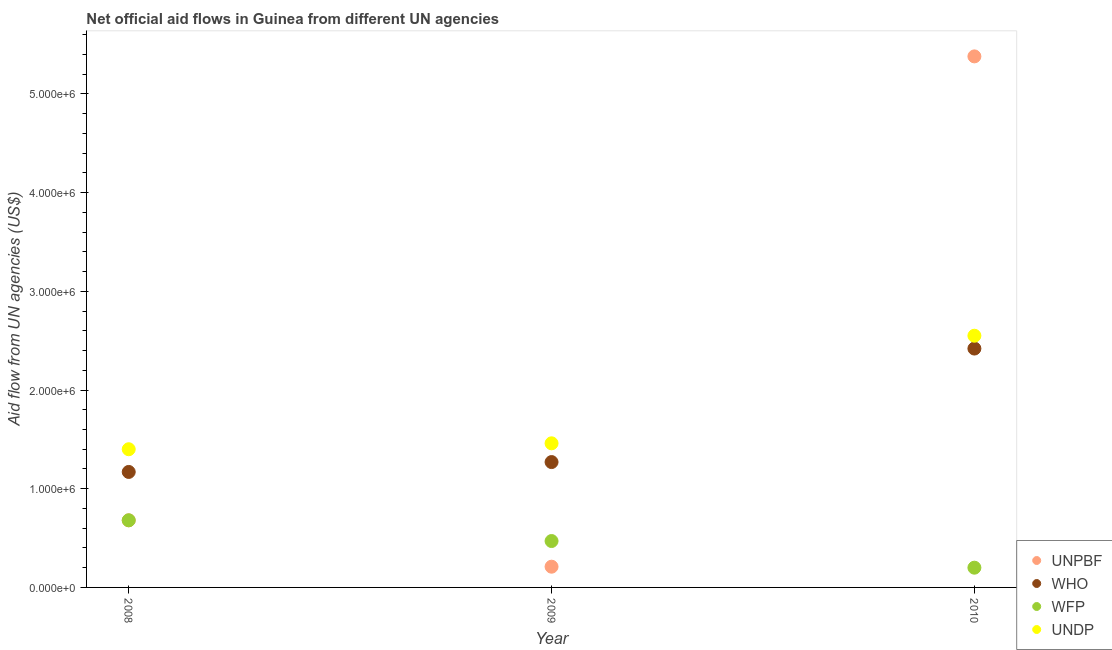What is the amount of aid given by undp in 2010?
Ensure brevity in your answer.  2.55e+06. Across all years, what is the maximum amount of aid given by who?
Keep it short and to the point. 2.42e+06. Across all years, what is the minimum amount of aid given by wfp?
Offer a very short reply. 2.00e+05. In which year was the amount of aid given by undp maximum?
Offer a terse response. 2010. What is the total amount of aid given by undp in the graph?
Your answer should be compact. 5.41e+06. What is the difference between the amount of aid given by who in 2009 and that in 2010?
Offer a terse response. -1.15e+06. What is the difference between the amount of aid given by unpbf in 2009 and the amount of aid given by who in 2008?
Make the answer very short. -9.60e+05. What is the average amount of aid given by undp per year?
Your answer should be compact. 1.80e+06. In the year 2009, what is the difference between the amount of aid given by wfp and amount of aid given by undp?
Your response must be concise. -9.90e+05. In how many years, is the amount of aid given by unpbf greater than 2600000 US$?
Your response must be concise. 1. What is the ratio of the amount of aid given by undp in 2008 to that in 2009?
Keep it short and to the point. 0.96. What is the difference between the highest and the second highest amount of aid given by unpbf?
Ensure brevity in your answer.  4.70e+06. What is the difference between the highest and the lowest amount of aid given by who?
Your answer should be very brief. 1.25e+06. In how many years, is the amount of aid given by wfp greater than the average amount of aid given by wfp taken over all years?
Offer a very short reply. 2. How many years are there in the graph?
Your response must be concise. 3. Are the values on the major ticks of Y-axis written in scientific E-notation?
Make the answer very short. Yes. Does the graph contain any zero values?
Ensure brevity in your answer.  No. Does the graph contain grids?
Give a very brief answer. No. Where does the legend appear in the graph?
Give a very brief answer. Bottom right. What is the title of the graph?
Ensure brevity in your answer.  Net official aid flows in Guinea from different UN agencies. What is the label or title of the Y-axis?
Your answer should be compact. Aid flow from UN agencies (US$). What is the Aid flow from UN agencies (US$) of UNPBF in 2008?
Offer a terse response. 6.80e+05. What is the Aid flow from UN agencies (US$) of WHO in 2008?
Ensure brevity in your answer.  1.17e+06. What is the Aid flow from UN agencies (US$) of WFP in 2008?
Provide a succinct answer. 6.80e+05. What is the Aid flow from UN agencies (US$) in UNDP in 2008?
Give a very brief answer. 1.40e+06. What is the Aid flow from UN agencies (US$) in WHO in 2009?
Keep it short and to the point. 1.27e+06. What is the Aid flow from UN agencies (US$) in UNDP in 2009?
Offer a terse response. 1.46e+06. What is the Aid flow from UN agencies (US$) of UNPBF in 2010?
Ensure brevity in your answer.  5.38e+06. What is the Aid flow from UN agencies (US$) of WHO in 2010?
Make the answer very short. 2.42e+06. What is the Aid flow from UN agencies (US$) in UNDP in 2010?
Your answer should be very brief. 2.55e+06. Across all years, what is the maximum Aid flow from UN agencies (US$) in UNPBF?
Give a very brief answer. 5.38e+06. Across all years, what is the maximum Aid flow from UN agencies (US$) in WHO?
Make the answer very short. 2.42e+06. Across all years, what is the maximum Aid flow from UN agencies (US$) of WFP?
Your answer should be very brief. 6.80e+05. Across all years, what is the maximum Aid flow from UN agencies (US$) in UNDP?
Offer a very short reply. 2.55e+06. Across all years, what is the minimum Aid flow from UN agencies (US$) in WHO?
Offer a very short reply. 1.17e+06. Across all years, what is the minimum Aid flow from UN agencies (US$) of UNDP?
Your answer should be compact. 1.40e+06. What is the total Aid flow from UN agencies (US$) in UNPBF in the graph?
Make the answer very short. 6.27e+06. What is the total Aid flow from UN agencies (US$) in WHO in the graph?
Make the answer very short. 4.86e+06. What is the total Aid flow from UN agencies (US$) in WFP in the graph?
Provide a short and direct response. 1.35e+06. What is the total Aid flow from UN agencies (US$) of UNDP in the graph?
Your answer should be very brief. 5.41e+06. What is the difference between the Aid flow from UN agencies (US$) of WHO in 2008 and that in 2009?
Make the answer very short. -1.00e+05. What is the difference between the Aid flow from UN agencies (US$) in WFP in 2008 and that in 2009?
Give a very brief answer. 2.10e+05. What is the difference between the Aid flow from UN agencies (US$) in UNPBF in 2008 and that in 2010?
Make the answer very short. -4.70e+06. What is the difference between the Aid flow from UN agencies (US$) in WHO in 2008 and that in 2010?
Your answer should be very brief. -1.25e+06. What is the difference between the Aid flow from UN agencies (US$) of WFP in 2008 and that in 2010?
Give a very brief answer. 4.80e+05. What is the difference between the Aid flow from UN agencies (US$) in UNDP in 2008 and that in 2010?
Provide a short and direct response. -1.15e+06. What is the difference between the Aid flow from UN agencies (US$) of UNPBF in 2009 and that in 2010?
Your answer should be compact. -5.17e+06. What is the difference between the Aid flow from UN agencies (US$) of WHO in 2009 and that in 2010?
Offer a very short reply. -1.15e+06. What is the difference between the Aid flow from UN agencies (US$) of UNDP in 2009 and that in 2010?
Offer a terse response. -1.09e+06. What is the difference between the Aid flow from UN agencies (US$) in UNPBF in 2008 and the Aid flow from UN agencies (US$) in WHO in 2009?
Ensure brevity in your answer.  -5.90e+05. What is the difference between the Aid flow from UN agencies (US$) in UNPBF in 2008 and the Aid flow from UN agencies (US$) in UNDP in 2009?
Keep it short and to the point. -7.80e+05. What is the difference between the Aid flow from UN agencies (US$) of WFP in 2008 and the Aid flow from UN agencies (US$) of UNDP in 2009?
Ensure brevity in your answer.  -7.80e+05. What is the difference between the Aid flow from UN agencies (US$) in UNPBF in 2008 and the Aid flow from UN agencies (US$) in WHO in 2010?
Ensure brevity in your answer.  -1.74e+06. What is the difference between the Aid flow from UN agencies (US$) of UNPBF in 2008 and the Aid flow from UN agencies (US$) of WFP in 2010?
Your answer should be compact. 4.80e+05. What is the difference between the Aid flow from UN agencies (US$) in UNPBF in 2008 and the Aid flow from UN agencies (US$) in UNDP in 2010?
Keep it short and to the point. -1.87e+06. What is the difference between the Aid flow from UN agencies (US$) in WHO in 2008 and the Aid flow from UN agencies (US$) in WFP in 2010?
Keep it short and to the point. 9.70e+05. What is the difference between the Aid flow from UN agencies (US$) in WHO in 2008 and the Aid flow from UN agencies (US$) in UNDP in 2010?
Provide a short and direct response. -1.38e+06. What is the difference between the Aid flow from UN agencies (US$) in WFP in 2008 and the Aid flow from UN agencies (US$) in UNDP in 2010?
Keep it short and to the point. -1.87e+06. What is the difference between the Aid flow from UN agencies (US$) of UNPBF in 2009 and the Aid flow from UN agencies (US$) of WHO in 2010?
Ensure brevity in your answer.  -2.21e+06. What is the difference between the Aid flow from UN agencies (US$) in UNPBF in 2009 and the Aid flow from UN agencies (US$) in UNDP in 2010?
Your answer should be very brief. -2.34e+06. What is the difference between the Aid flow from UN agencies (US$) in WHO in 2009 and the Aid flow from UN agencies (US$) in WFP in 2010?
Make the answer very short. 1.07e+06. What is the difference between the Aid flow from UN agencies (US$) of WHO in 2009 and the Aid flow from UN agencies (US$) of UNDP in 2010?
Give a very brief answer. -1.28e+06. What is the difference between the Aid flow from UN agencies (US$) of WFP in 2009 and the Aid flow from UN agencies (US$) of UNDP in 2010?
Offer a terse response. -2.08e+06. What is the average Aid flow from UN agencies (US$) of UNPBF per year?
Your response must be concise. 2.09e+06. What is the average Aid flow from UN agencies (US$) of WHO per year?
Your answer should be compact. 1.62e+06. What is the average Aid flow from UN agencies (US$) of UNDP per year?
Keep it short and to the point. 1.80e+06. In the year 2008, what is the difference between the Aid flow from UN agencies (US$) of UNPBF and Aid flow from UN agencies (US$) of WHO?
Offer a terse response. -4.90e+05. In the year 2008, what is the difference between the Aid flow from UN agencies (US$) in UNPBF and Aid flow from UN agencies (US$) in WFP?
Ensure brevity in your answer.  0. In the year 2008, what is the difference between the Aid flow from UN agencies (US$) in UNPBF and Aid flow from UN agencies (US$) in UNDP?
Provide a succinct answer. -7.20e+05. In the year 2008, what is the difference between the Aid flow from UN agencies (US$) of WHO and Aid flow from UN agencies (US$) of UNDP?
Provide a succinct answer. -2.30e+05. In the year 2008, what is the difference between the Aid flow from UN agencies (US$) in WFP and Aid flow from UN agencies (US$) in UNDP?
Provide a succinct answer. -7.20e+05. In the year 2009, what is the difference between the Aid flow from UN agencies (US$) in UNPBF and Aid flow from UN agencies (US$) in WHO?
Provide a succinct answer. -1.06e+06. In the year 2009, what is the difference between the Aid flow from UN agencies (US$) of UNPBF and Aid flow from UN agencies (US$) of WFP?
Provide a short and direct response. -2.60e+05. In the year 2009, what is the difference between the Aid flow from UN agencies (US$) of UNPBF and Aid flow from UN agencies (US$) of UNDP?
Ensure brevity in your answer.  -1.25e+06. In the year 2009, what is the difference between the Aid flow from UN agencies (US$) in WHO and Aid flow from UN agencies (US$) in WFP?
Your answer should be very brief. 8.00e+05. In the year 2009, what is the difference between the Aid flow from UN agencies (US$) of WHO and Aid flow from UN agencies (US$) of UNDP?
Make the answer very short. -1.90e+05. In the year 2009, what is the difference between the Aid flow from UN agencies (US$) in WFP and Aid flow from UN agencies (US$) in UNDP?
Offer a terse response. -9.90e+05. In the year 2010, what is the difference between the Aid flow from UN agencies (US$) in UNPBF and Aid flow from UN agencies (US$) in WHO?
Offer a very short reply. 2.96e+06. In the year 2010, what is the difference between the Aid flow from UN agencies (US$) of UNPBF and Aid flow from UN agencies (US$) of WFP?
Your answer should be compact. 5.18e+06. In the year 2010, what is the difference between the Aid flow from UN agencies (US$) in UNPBF and Aid flow from UN agencies (US$) in UNDP?
Give a very brief answer. 2.83e+06. In the year 2010, what is the difference between the Aid flow from UN agencies (US$) in WHO and Aid flow from UN agencies (US$) in WFP?
Give a very brief answer. 2.22e+06. In the year 2010, what is the difference between the Aid flow from UN agencies (US$) in WHO and Aid flow from UN agencies (US$) in UNDP?
Offer a terse response. -1.30e+05. In the year 2010, what is the difference between the Aid flow from UN agencies (US$) of WFP and Aid flow from UN agencies (US$) of UNDP?
Your response must be concise. -2.35e+06. What is the ratio of the Aid flow from UN agencies (US$) of UNPBF in 2008 to that in 2009?
Provide a succinct answer. 3.24. What is the ratio of the Aid flow from UN agencies (US$) in WHO in 2008 to that in 2009?
Make the answer very short. 0.92. What is the ratio of the Aid flow from UN agencies (US$) of WFP in 2008 to that in 2009?
Your response must be concise. 1.45. What is the ratio of the Aid flow from UN agencies (US$) of UNDP in 2008 to that in 2009?
Make the answer very short. 0.96. What is the ratio of the Aid flow from UN agencies (US$) in UNPBF in 2008 to that in 2010?
Ensure brevity in your answer.  0.13. What is the ratio of the Aid flow from UN agencies (US$) of WHO in 2008 to that in 2010?
Make the answer very short. 0.48. What is the ratio of the Aid flow from UN agencies (US$) of UNDP in 2008 to that in 2010?
Make the answer very short. 0.55. What is the ratio of the Aid flow from UN agencies (US$) of UNPBF in 2009 to that in 2010?
Your answer should be compact. 0.04. What is the ratio of the Aid flow from UN agencies (US$) of WHO in 2009 to that in 2010?
Make the answer very short. 0.52. What is the ratio of the Aid flow from UN agencies (US$) of WFP in 2009 to that in 2010?
Make the answer very short. 2.35. What is the ratio of the Aid flow from UN agencies (US$) of UNDP in 2009 to that in 2010?
Your response must be concise. 0.57. What is the difference between the highest and the second highest Aid flow from UN agencies (US$) in UNPBF?
Your answer should be compact. 4.70e+06. What is the difference between the highest and the second highest Aid flow from UN agencies (US$) in WHO?
Give a very brief answer. 1.15e+06. What is the difference between the highest and the second highest Aid flow from UN agencies (US$) of WFP?
Offer a terse response. 2.10e+05. What is the difference between the highest and the second highest Aid flow from UN agencies (US$) in UNDP?
Keep it short and to the point. 1.09e+06. What is the difference between the highest and the lowest Aid flow from UN agencies (US$) in UNPBF?
Provide a succinct answer. 5.17e+06. What is the difference between the highest and the lowest Aid flow from UN agencies (US$) in WHO?
Offer a terse response. 1.25e+06. What is the difference between the highest and the lowest Aid flow from UN agencies (US$) of WFP?
Keep it short and to the point. 4.80e+05. What is the difference between the highest and the lowest Aid flow from UN agencies (US$) in UNDP?
Ensure brevity in your answer.  1.15e+06. 